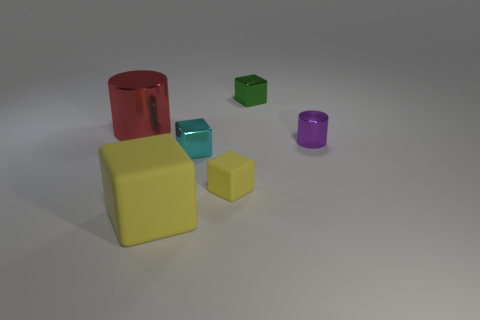Subtract all cyan blocks. How many blocks are left? 3 Add 3 metallic cylinders. How many objects exist? 9 Subtract all green blocks. How many blocks are left? 3 Subtract 2 cylinders. How many cylinders are left? 0 Subtract all cylinders. How many objects are left? 4 Subtract all cyan cubes. Subtract all green cylinders. How many cubes are left? 3 Subtract all cyan blocks. How many red cylinders are left? 1 Subtract all green shiny blocks. Subtract all red matte cylinders. How many objects are left? 5 Add 4 tiny yellow matte cubes. How many tiny yellow matte cubes are left? 5 Add 5 tiny purple cylinders. How many tiny purple cylinders exist? 6 